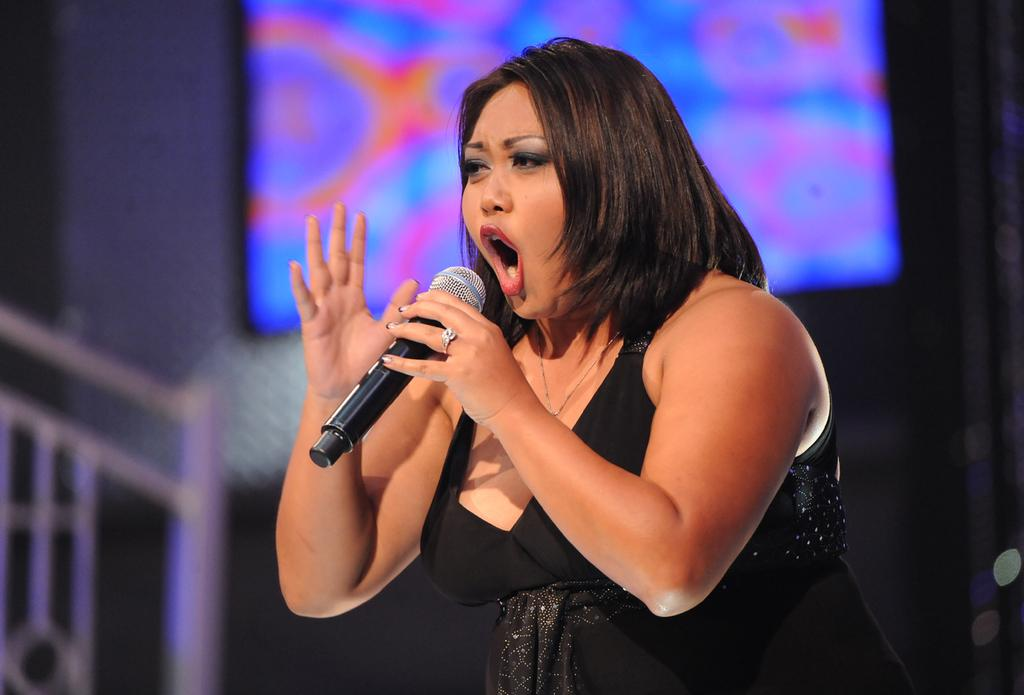Who is the main subject in the image? There is a woman in the image. What is the woman holding in the image? The woman is holding a mic. What might the woman be doing with the mic? The woman might be singing or talking with the mic. What is the woman wearing in the image? The woman is wearing a black dress. What can be seen in the background of the image? There is a projector screen in the background of the image. How many horses can be seen grazing on the branch in the image? There are no horses or branches present in the image. What type of bead is hanging from the woman's dress in the image? There is no bead hanging from the woman's dress in the image. 